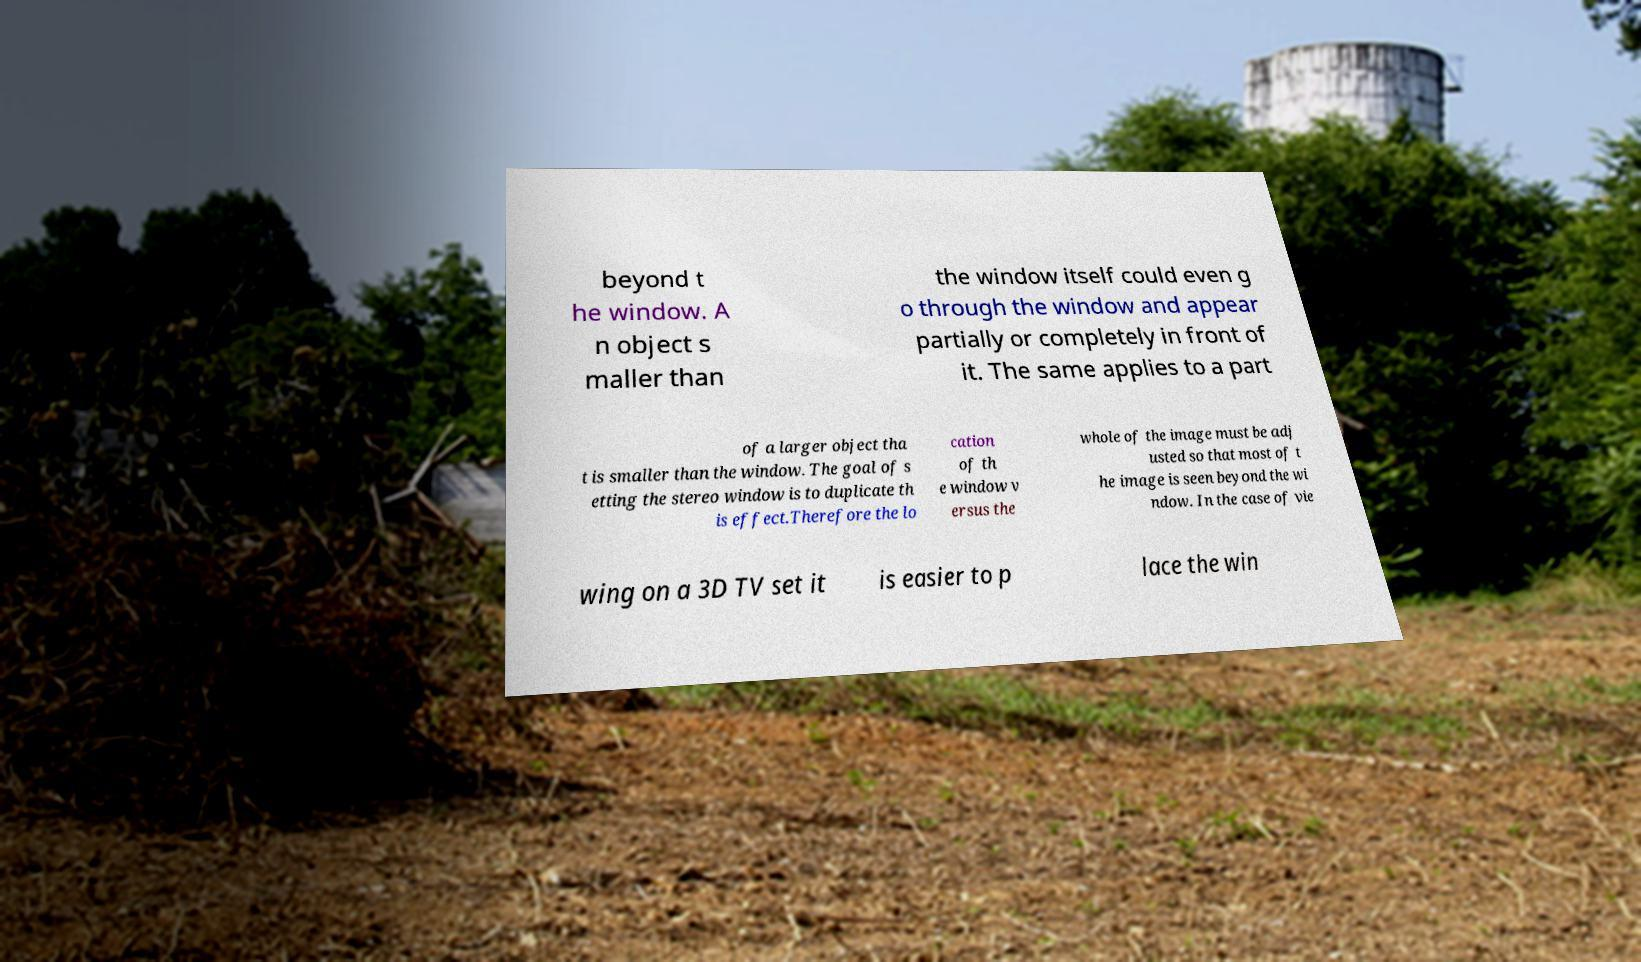Please identify and transcribe the text found in this image. beyond t he window. A n object s maller than the window itself could even g o through the window and appear partially or completely in front of it. The same applies to a part of a larger object tha t is smaller than the window. The goal of s etting the stereo window is to duplicate th is effect.Therefore the lo cation of th e window v ersus the whole of the image must be adj usted so that most of t he image is seen beyond the wi ndow. In the case of vie wing on a 3D TV set it is easier to p lace the win 